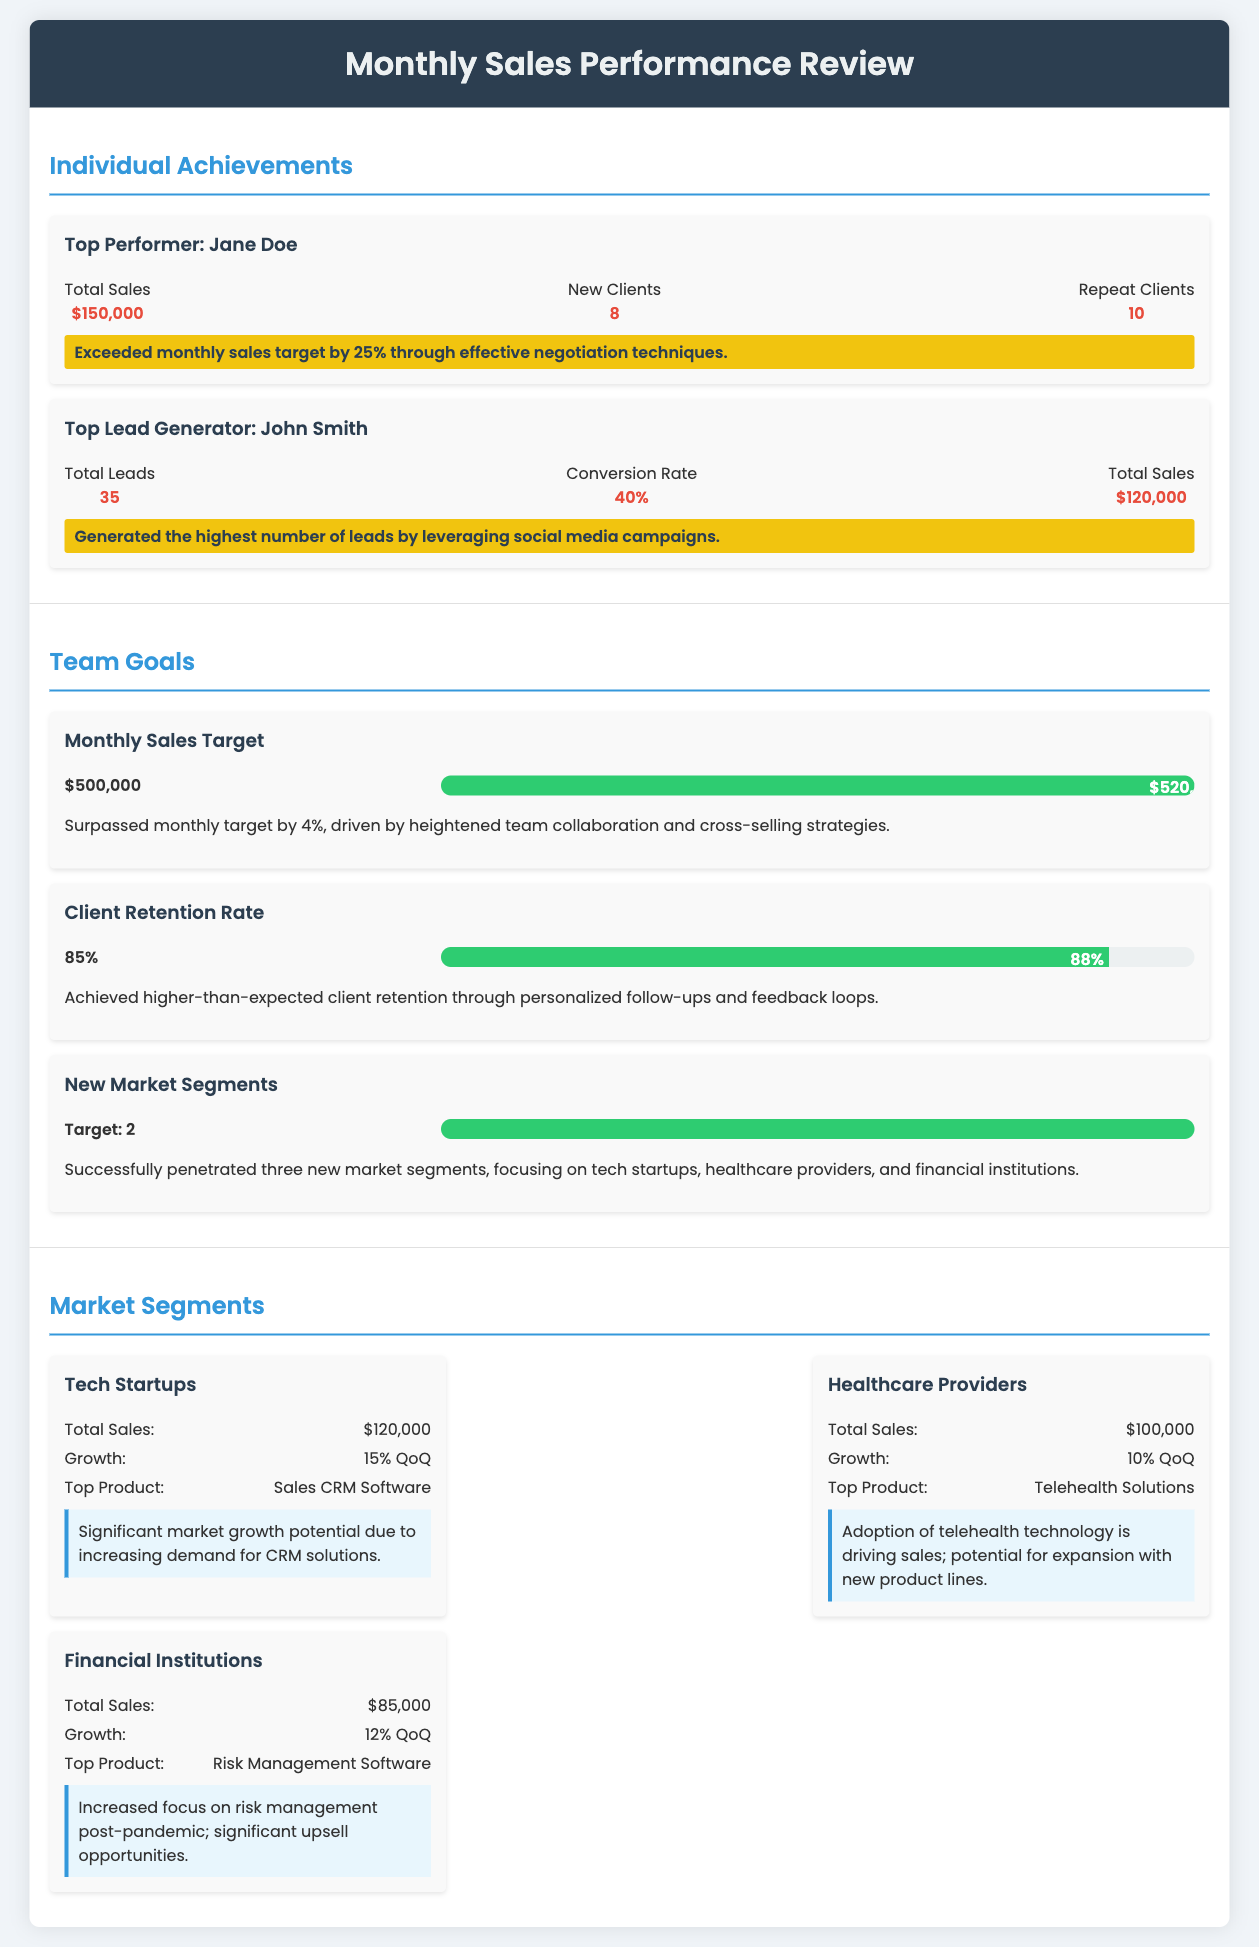What is the name of the top performer? The top performer mentioned in the document is Jane Doe.
Answer: Jane Doe How much did Jane Doe exceed her sales target by? Jane Doe exceeded her monthly sales target by 25%.
Answer: 25% What was the total sales for John Smith? The total sales for John Smith is $120,000.
Answer: $120,000 What was the monthly sales target? The monthly sales target set in the document was $500,000.
Answer: $500,000 What percentage was the client retention rate achieved? The client retention rate achieved was 88%.
Answer: 88% How many new market segments were achieved? The document states that 3 new market segments were successfully penetrated.
Answer: 3 Which market segment had the highest total sales? The market segment with the highest total sales is Tech Startups.
Answer: Tech Startups What was the top product for Healthcare Providers? The top product for Healthcare Providers is Telehealth Solutions.
Answer: Telehealth Solutions What is the growth percentage for Financial Institutions? The growth percentage for Financial Institutions is 12% QoQ.
Answer: 12% QoQ 